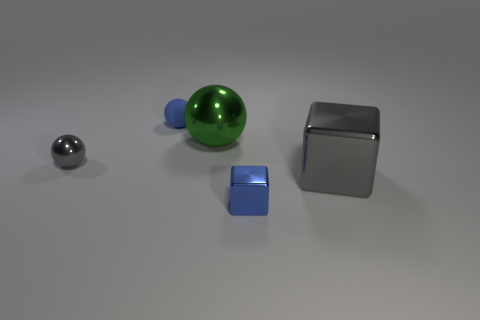Add 5 tiny gray metallic things. How many objects exist? 10 Subtract all balls. How many objects are left? 2 Add 1 small metallic spheres. How many small metallic spheres exist? 2 Subtract 1 blue balls. How many objects are left? 4 Subtract all small yellow rubber blocks. Subtract all blue matte objects. How many objects are left? 4 Add 2 small shiny things. How many small shiny things are left? 4 